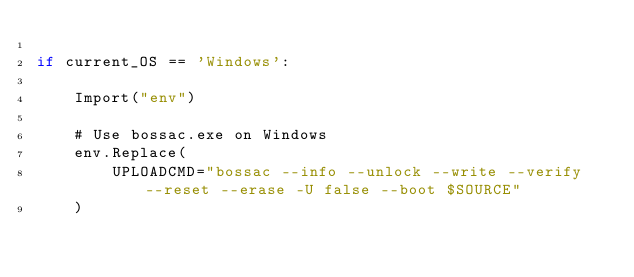Convert code to text. <code><loc_0><loc_0><loc_500><loc_500><_Python_>
if current_OS == 'Windows':

	Import("env")

	# Use bossac.exe on Windows
	env.Replace(
	    UPLOADCMD="bossac --info --unlock --write --verify --reset --erase -U false --boot $SOURCE"
	)
</code> 